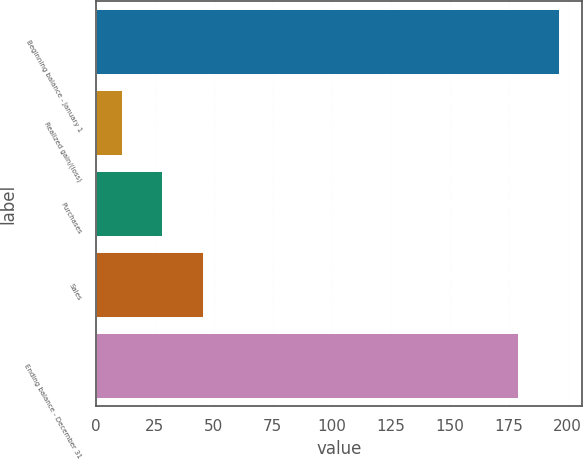<chart> <loc_0><loc_0><loc_500><loc_500><bar_chart><fcel>Beginning balance - January 1<fcel>Realized gain/(loss)<fcel>Purchases<fcel>Sales<fcel>Ending balance - December 31<nl><fcel>196.3<fcel>11<fcel>28.3<fcel>45.6<fcel>179<nl></chart> 